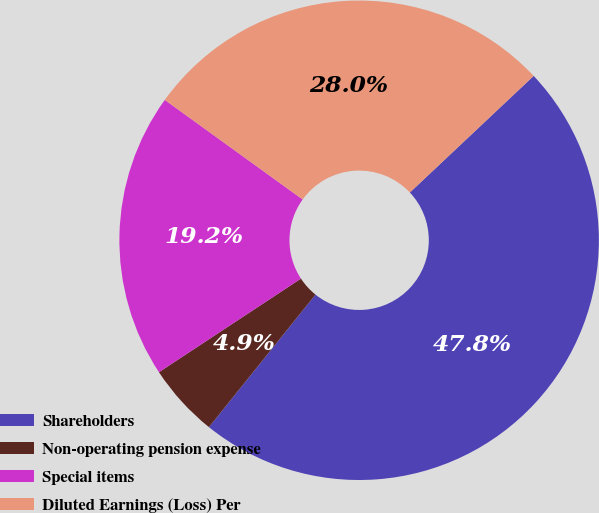Convert chart to OTSL. <chart><loc_0><loc_0><loc_500><loc_500><pie_chart><fcel>Shareholders<fcel>Non-operating pension expense<fcel>Special items<fcel>Diluted Earnings (Loss) Per<nl><fcel>47.8%<fcel>4.95%<fcel>19.23%<fcel>28.02%<nl></chart> 